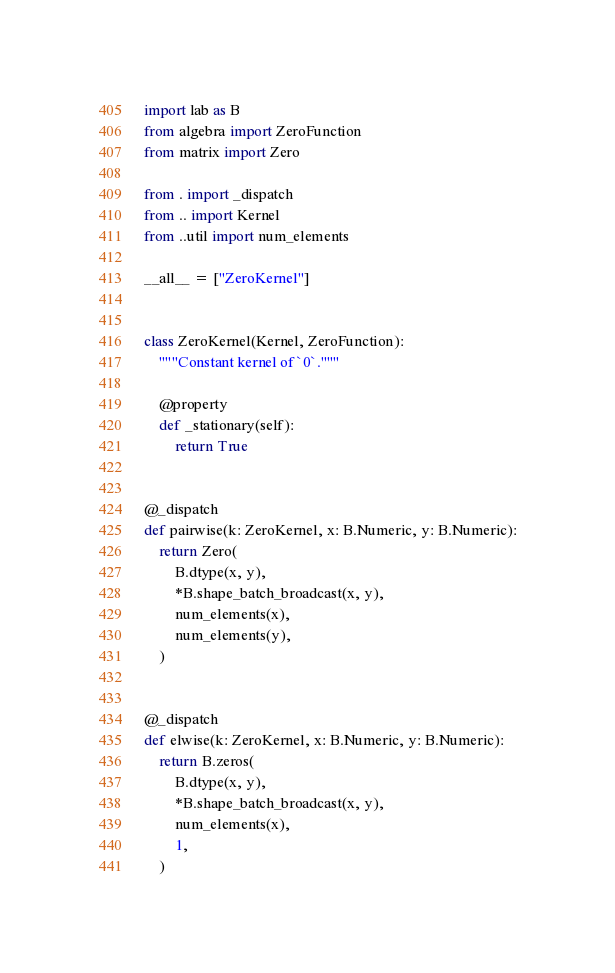Convert code to text. <code><loc_0><loc_0><loc_500><loc_500><_Python_>import lab as B
from algebra import ZeroFunction
from matrix import Zero

from . import _dispatch
from .. import Kernel
from ..util import num_elements

__all__ = ["ZeroKernel"]


class ZeroKernel(Kernel, ZeroFunction):
    """Constant kernel of `0`."""

    @property
    def _stationary(self):
        return True


@_dispatch
def pairwise(k: ZeroKernel, x: B.Numeric, y: B.Numeric):
    return Zero(
        B.dtype(x, y),
        *B.shape_batch_broadcast(x, y),
        num_elements(x),
        num_elements(y),
    )


@_dispatch
def elwise(k: ZeroKernel, x: B.Numeric, y: B.Numeric):
    return B.zeros(
        B.dtype(x, y),
        *B.shape_batch_broadcast(x, y),
        num_elements(x),
        1,
    )
</code> 